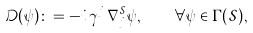<formula> <loc_0><loc_0><loc_500><loc_500>\mathcal { D } ( \psi ) \colon = - i \, \gamma ^ { j } \, \nabla _ { j } ^ { \mathcal { S } } \psi , \quad \forall \psi \in \Gamma ( \mathcal { S } ) ,</formula> 